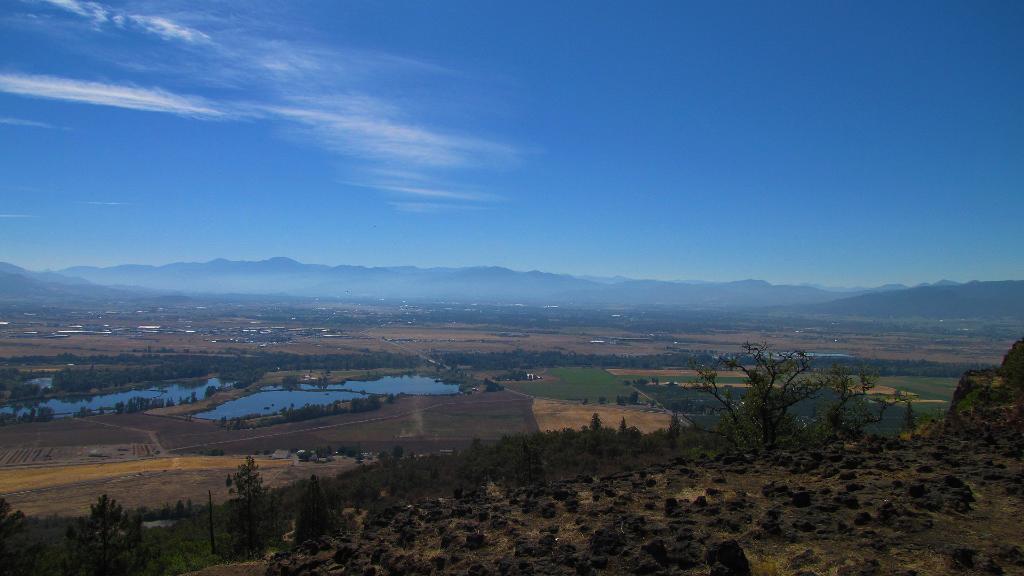Describe this image in one or two sentences. In this image at the top there is the sky, in the middle there is the hill, trees, water, in the bottom left there are planets visible. 